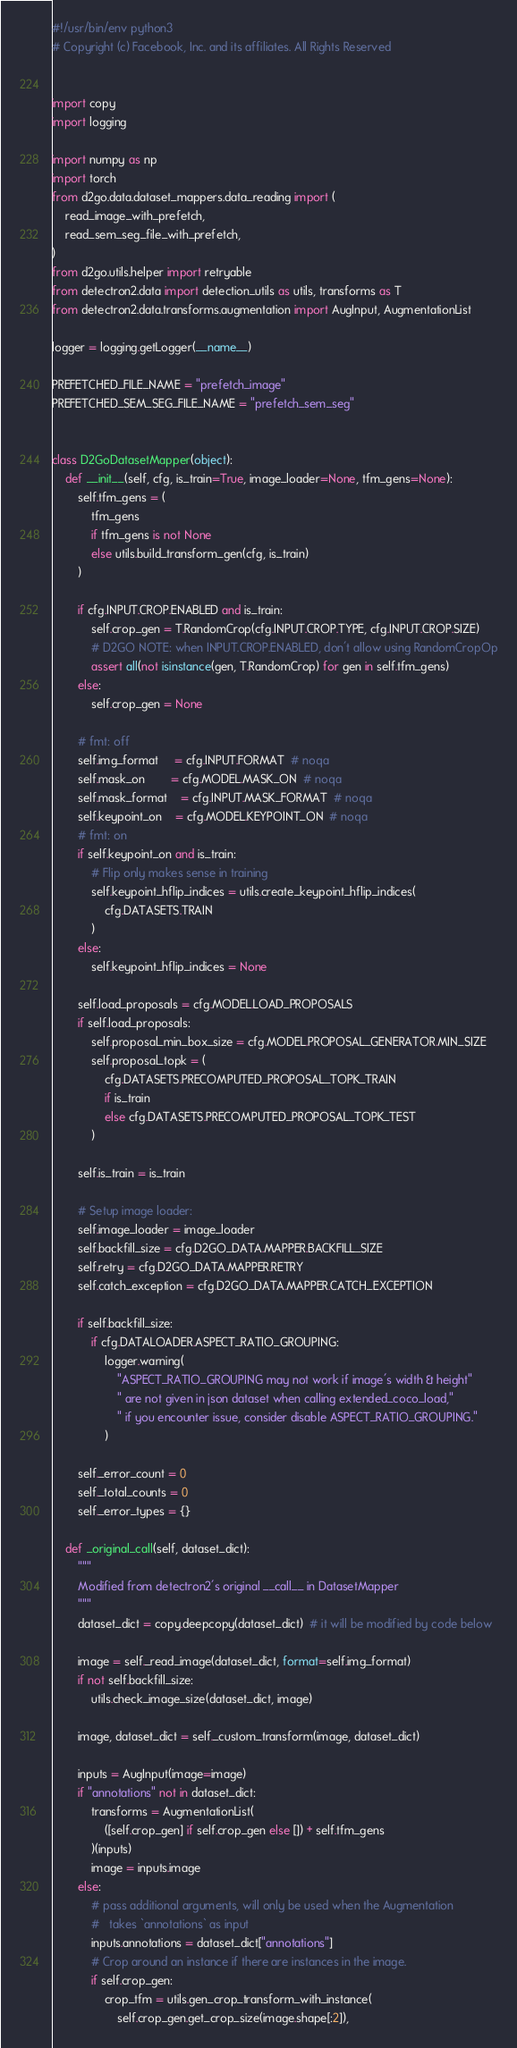Convert code to text. <code><loc_0><loc_0><loc_500><loc_500><_Python_>#!/usr/bin/env python3
# Copyright (c) Facebook, Inc. and its affiliates. All Rights Reserved


import copy
import logging

import numpy as np
import torch
from d2go.data.dataset_mappers.data_reading import (
    read_image_with_prefetch,
    read_sem_seg_file_with_prefetch,
)
from d2go.utils.helper import retryable
from detectron2.data import detection_utils as utils, transforms as T
from detectron2.data.transforms.augmentation import AugInput, AugmentationList

logger = logging.getLogger(__name__)

PREFETCHED_FILE_NAME = "prefetch_image"
PREFETCHED_SEM_SEG_FILE_NAME = "prefetch_sem_seg"


class D2GoDatasetMapper(object):
    def __init__(self, cfg, is_train=True, image_loader=None, tfm_gens=None):
        self.tfm_gens = (
            tfm_gens
            if tfm_gens is not None
            else utils.build_transform_gen(cfg, is_train)
        )

        if cfg.INPUT.CROP.ENABLED and is_train:
            self.crop_gen = T.RandomCrop(cfg.INPUT.CROP.TYPE, cfg.INPUT.CROP.SIZE)
            # D2GO NOTE: when INPUT.CROP.ENABLED, don't allow using RandomCropOp
            assert all(not isinstance(gen, T.RandomCrop) for gen in self.tfm_gens)
        else:
            self.crop_gen = None

        # fmt: off
        self.img_format     = cfg.INPUT.FORMAT  # noqa
        self.mask_on        = cfg.MODEL.MASK_ON  # noqa
        self.mask_format    = cfg.INPUT.MASK_FORMAT  # noqa
        self.keypoint_on    = cfg.MODEL.KEYPOINT_ON  # noqa
        # fmt: on
        if self.keypoint_on and is_train:
            # Flip only makes sense in training
            self.keypoint_hflip_indices = utils.create_keypoint_hflip_indices(
                cfg.DATASETS.TRAIN
            )
        else:
            self.keypoint_hflip_indices = None

        self.load_proposals = cfg.MODEL.LOAD_PROPOSALS
        if self.load_proposals:
            self.proposal_min_box_size = cfg.MODEL.PROPOSAL_GENERATOR.MIN_SIZE
            self.proposal_topk = (
                cfg.DATASETS.PRECOMPUTED_PROPOSAL_TOPK_TRAIN
                if is_train
                else cfg.DATASETS.PRECOMPUTED_PROPOSAL_TOPK_TEST
            )

        self.is_train = is_train

        # Setup image loader:
        self.image_loader = image_loader
        self.backfill_size = cfg.D2GO_DATA.MAPPER.BACKFILL_SIZE
        self.retry = cfg.D2GO_DATA.MAPPER.RETRY
        self.catch_exception = cfg.D2GO_DATA.MAPPER.CATCH_EXCEPTION

        if self.backfill_size:
            if cfg.DATALOADER.ASPECT_RATIO_GROUPING:
                logger.warning(
                    "ASPECT_RATIO_GROUPING may not work if image's width & height"
                    " are not given in json dataset when calling extended_coco_load,"
                    " if you encounter issue, consider disable ASPECT_RATIO_GROUPING."
                )

        self._error_count = 0
        self._total_counts = 0
        self._error_types = {}

    def _original_call(self, dataset_dict):
        """
        Modified from detectron2's original __call__ in DatasetMapper
        """
        dataset_dict = copy.deepcopy(dataset_dict)  # it will be modified by code below

        image = self._read_image(dataset_dict, format=self.img_format)
        if not self.backfill_size:
            utils.check_image_size(dataset_dict, image)

        image, dataset_dict = self._custom_transform(image, dataset_dict)

        inputs = AugInput(image=image)
        if "annotations" not in dataset_dict:
            transforms = AugmentationList(
                ([self.crop_gen] if self.crop_gen else []) + self.tfm_gens
            )(inputs)
            image = inputs.image
        else:
            # pass additional arguments, will only be used when the Augmentation
            #   takes `annotations` as input
            inputs.annotations = dataset_dict["annotations"]
            # Crop around an instance if there are instances in the image.
            if self.crop_gen:
                crop_tfm = utils.gen_crop_transform_with_instance(
                    self.crop_gen.get_crop_size(image.shape[:2]),</code> 